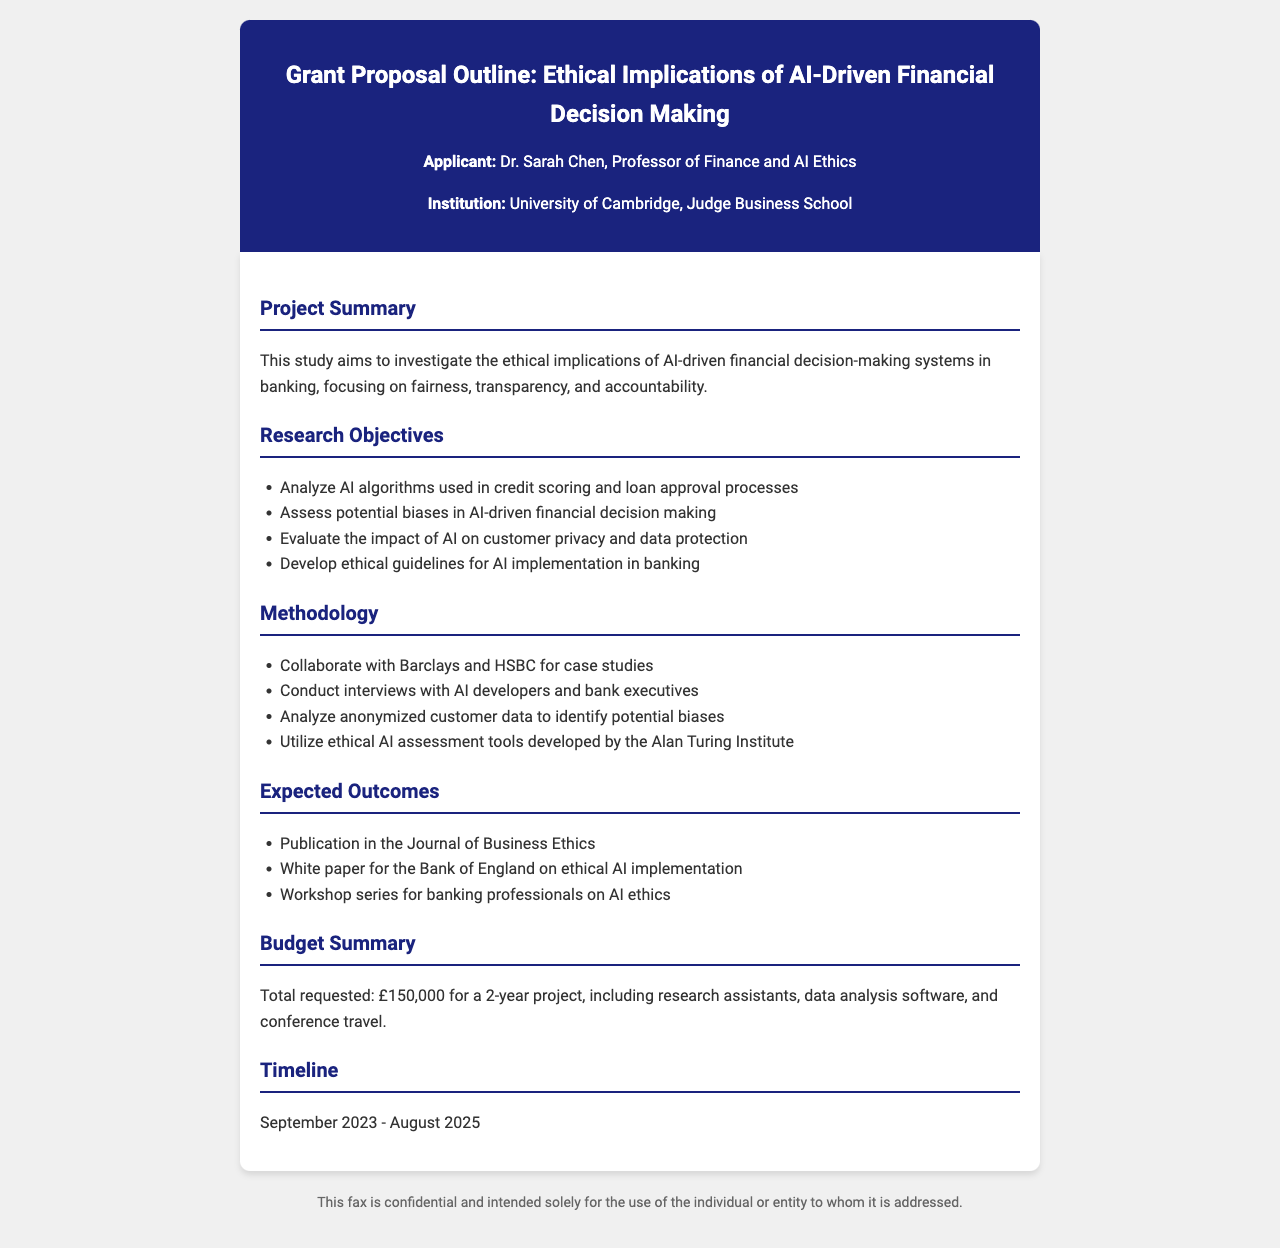What is the name of the applicant? The applicant's name is mentioned in the document as Dr. Sarah Chen.
Answer: Dr. Sarah Chen What is the total budget requested for the project? The document states the total requested budget for the project is £150,000.
Answer: £150,000 Which institution is Dr. Sarah Chen affiliated with? The document specifies that Dr. Sarah Chen is affiliated with the University of Cambridge, Judge Business School.
Answer: University of Cambridge, Judge Business School What is one of the research objectives? The document lists multiple research objectives, one of which is to analyze AI algorithms used in credit scoring and loan approval processes.
Answer: Analyze AI algorithms used in credit scoring and loan approval processes What is the timeline for the project? The timeline provided in the document states the project runs from September 2023 to August 2025.
Answer: September 2023 - August 2025 Which organizations are mentioned for collaboration in the methodology? The methodology mentions collaboration with Barclays and HSBC for case studies.
Answer: Barclays and HSBC What type of publication is expected as an outcome? The document indicates that a publication in the Journal of Business Ethics is expected as an outcome.
Answer: Journal of Business Ethics What will the white paper be for? The expected white paper mentioned in the document is for the Bank of England on ethical AI implementation.
Answer: Bank of England on ethical AI implementation What research tools will be utilized? The document states that ethical AI assessment tools developed by the Alan Turing Institute will be utilized.
Answer: Ethical AI assessment tools developed by the Alan Turing Institute 